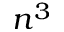<formula> <loc_0><loc_0><loc_500><loc_500>n ^ { 3 }</formula> 